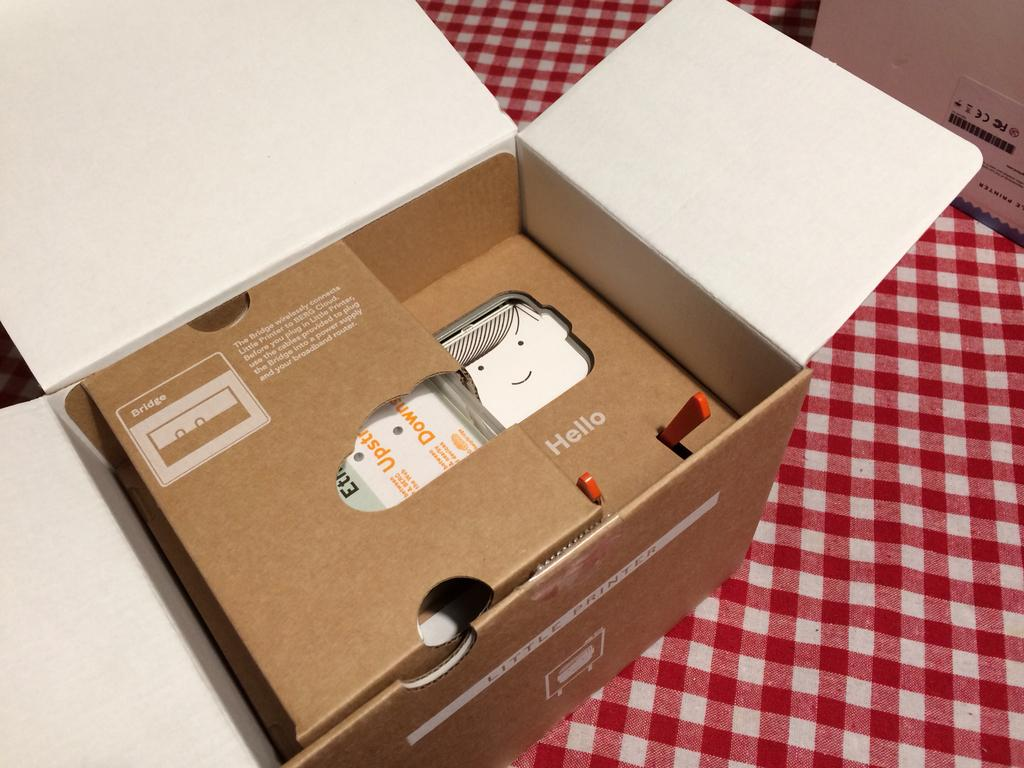<image>
Write a terse but informative summary of the picture. A box for Little Printer is opened and is resting on a kitchen table. 